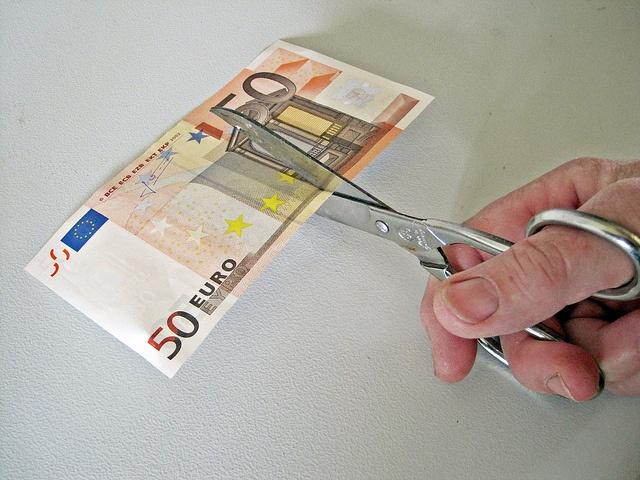Describe the objects in this image and their specific colors. I can see people in lightgray, brown, gray, maroon, and darkgray tones and scissors in lightgray, gray, and darkgray tones in this image. 